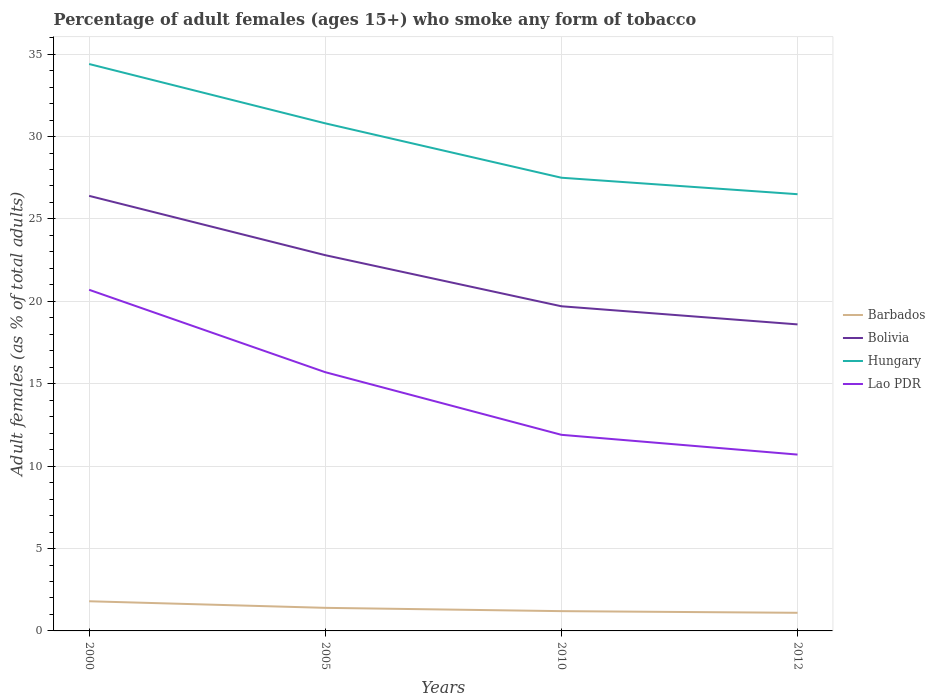How many different coloured lines are there?
Provide a short and direct response. 4. Does the line corresponding to Bolivia intersect with the line corresponding to Barbados?
Your response must be concise. No. Across all years, what is the maximum percentage of adult females who smoke in Barbados?
Provide a succinct answer. 1.1. What is the total percentage of adult females who smoke in Bolivia in the graph?
Provide a short and direct response. 1.1. What is the difference between the highest and the second highest percentage of adult females who smoke in Barbados?
Provide a short and direct response. 0.7. What is the difference between the highest and the lowest percentage of adult females who smoke in Barbados?
Ensure brevity in your answer.  2. How many lines are there?
Your answer should be very brief. 4. How many years are there in the graph?
Offer a terse response. 4. What is the difference between two consecutive major ticks on the Y-axis?
Provide a succinct answer. 5. Are the values on the major ticks of Y-axis written in scientific E-notation?
Make the answer very short. No. Does the graph contain any zero values?
Offer a very short reply. No. Does the graph contain grids?
Provide a succinct answer. Yes. How are the legend labels stacked?
Your response must be concise. Vertical. What is the title of the graph?
Your answer should be compact. Percentage of adult females (ages 15+) who smoke any form of tobacco. Does "Iraq" appear as one of the legend labels in the graph?
Offer a terse response. No. What is the label or title of the Y-axis?
Provide a succinct answer. Adult females (as % of total adults). What is the Adult females (as % of total adults) of Barbados in 2000?
Keep it short and to the point. 1.8. What is the Adult females (as % of total adults) in Bolivia in 2000?
Your response must be concise. 26.4. What is the Adult females (as % of total adults) of Hungary in 2000?
Your answer should be very brief. 34.4. What is the Adult females (as % of total adults) in Lao PDR in 2000?
Give a very brief answer. 20.7. What is the Adult females (as % of total adults) of Barbados in 2005?
Your answer should be compact. 1.4. What is the Adult females (as % of total adults) of Bolivia in 2005?
Provide a short and direct response. 22.8. What is the Adult females (as % of total adults) in Hungary in 2005?
Your answer should be compact. 30.8. What is the Adult females (as % of total adults) of Bolivia in 2010?
Offer a terse response. 19.7. What is the Adult females (as % of total adults) in Hungary in 2010?
Keep it short and to the point. 27.5. What is the Adult females (as % of total adults) of Bolivia in 2012?
Provide a succinct answer. 18.6. Across all years, what is the maximum Adult females (as % of total adults) in Bolivia?
Ensure brevity in your answer.  26.4. Across all years, what is the maximum Adult females (as % of total adults) of Hungary?
Give a very brief answer. 34.4. Across all years, what is the maximum Adult females (as % of total adults) of Lao PDR?
Your answer should be very brief. 20.7. Across all years, what is the minimum Adult females (as % of total adults) of Bolivia?
Provide a succinct answer. 18.6. Across all years, what is the minimum Adult females (as % of total adults) of Lao PDR?
Give a very brief answer. 10.7. What is the total Adult females (as % of total adults) of Bolivia in the graph?
Your answer should be compact. 87.5. What is the total Adult females (as % of total adults) of Hungary in the graph?
Your response must be concise. 119.2. What is the difference between the Adult females (as % of total adults) in Bolivia in 2000 and that in 2005?
Keep it short and to the point. 3.6. What is the difference between the Adult females (as % of total adults) in Hungary in 2000 and that in 2005?
Your answer should be very brief. 3.6. What is the difference between the Adult females (as % of total adults) in Lao PDR in 2000 and that in 2005?
Offer a terse response. 5. What is the difference between the Adult females (as % of total adults) of Barbados in 2000 and that in 2010?
Your response must be concise. 0.6. What is the difference between the Adult females (as % of total adults) of Hungary in 2000 and that in 2010?
Keep it short and to the point. 6.9. What is the difference between the Adult females (as % of total adults) in Lao PDR in 2000 and that in 2010?
Offer a very short reply. 8.8. What is the difference between the Adult females (as % of total adults) in Barbados in 2000 and that in 2012?
Offer a terse response. 0.7. What is the difference between the Adult females (as % of total adults) in Lao PDR in 2000 and that in 2012?
Give a very brief answer. 10. What is the difference between the Adult females (as % of total adults) in Barbados in 2005 and that in 2010?
Your answer should be very brief. 0.2. What is the difference between the Adult females (as % of total adults) of Hungary in 2005 and that in 2010?
Your answer should be compact. 3.3. What is the difference between the Adult females (as % of total adults) in Barbados in 2005 and that in 2012?
Your answer should be compact. 0.3. What is the difference between the Adult females (as % of total adults) of Barbados in 2010 and that in 2012?
Offer a terse response. 0.1. What is the difference between the Adult females (as % of total adults) of Bolivia in 2010 and that in 2012?
Provide a succinct answer. 1.1. What is the difference between the Adult females (as % of total adults) in Hungary in 2010 and that in 2012?
Offer a very short reply. 1. What is the difference between the Adult females (as % of total adults) of Lao PDR in 2010 and that in 2012?
Your response must be concise. 1.2. What is the difference between the Adult females (as % of total adults) in Barbados in 2000 and the Adult females (as % of total adults) in Hungary in 2005?
Provide a short and direct response. -29. What is the difference between the Adult females (as % of total adults) of Barbados in 2000 and the Adult females (as % of total adults) of Lao PDR in 2005?
Your answer should be very brief. -13.9. What is the difference between the Adult females (as % of total adults) in Barbados in 2000 and the Adult females (as % of total adults) in Bolivia in 2010?
Keep it short and to the point. -17.9. What is the difference between the Adult females (as % of total adults) in Barbados in 2000 and the Adult females (as % of total adults) in Hungary in 2010?
Offer a very short reply. -25.7. What is the difference between the Adult females (as % of total adults) of Barbados in 2000 and the Adult females (as % of total adults) of Lao PDR in 2010?
Ensure brevity in your answer.  -10.1. What is the difference between the Adult females (as % of total adults) of Bolivia in 2000 and the Adult females (as % of total adults) of Lao PDR in 2010?
Your response must be concise. 14.5. What is the difference between the Adult females (as % of total adults) in Hungary in 2000 and the Adult females (as % of total adults) in Lao PDR in 2010?
Your answer should be compact. 22.5. What is the difference between the Adult females (as % of total adults) of Barbados in 2000 and the Adult females (as % of total adults) of Bolivia in 2012?
Offer a terse response. -16.8. What is the difference between the Adult females (as % of total adults) of Barbados in 2000 and the Adult females (as % of total adults) of Hungary in 2012?
Give a very brief answer. -24.7. What is the difference between the Adult females (as % of total adults) of Hungary in 2000 and the Adult females (as % of total adults) of Lao PDR in 2012?
Your answer should be very brief. 23.7. What is the difference between the Adult females (as % of total adults) of Barbados in 2005 and the Adult females (as % of total adults) of Bolivia in 2010?
Make the answer very short. -18.3. What is the difference between the Adult females (as % of total adults) in Barbados in 2005 and the Adult females (as % of total adults) in Hungary in 2010?
Make the answer very short. -26.1. What is the difference between the Adult females (as % of total adults) of Bolivia in 2005 and the Adult females (as % of total adults) of Lao PDR in 2010?
Give a very brief answer. 10.9. What is the difference between the Adult females (as % of total adults) in Barbados in 2005 and the Adult females (as % of total adults) in Bolivia in 2012?
Keep it short and to the point. -17.2. What is the difference between the Adult females (as % of total adults) in Barbados in 2005 and the Adult females (as % of total adults) in Hungary in 2012?
Your response must be concise. -25.1. What is the difference between the Adult females (as % of total adults) of Barbados in 2005 and the Adult females (as % of total adults) of Lao PDR in 2012?
Offer a very short reply. -9.3. What is the difference between the Adult females (as % of total adults) of Hungary in 2005 and the Adult females (as % of total adults) of Lao PDR in 2012?
Give a very brief answer. 20.1. What is the difference between the Adult females (as % of total adults) of Barbados in 2010 and the Adult females (as % of total adults) of Bolivia in 2012?
Offer a very short reply. -17.4. What is the difference between the Adult females (as % of total adults) in Barbados in 2010 and the Adult females (as % of total adults) in Hungary in 2012?
Your answer should be very brief. -25.3. What is the average Adult females (as % of total adults) in Barbados per year?
Make the answer very short. 1.38. What is the average Adult females (as % of total adults) in Bolivia per year?
Offer a terse response. 21.88. What is the average Adult females (as % of total adults) in Hungary per year?
Give a very brief answer. 29.8. What is the average Adult females (as % of total adults) in Lao PDR per year?
Your answer should be compact. 14.75. In the year 2000, what is the difference between the Adult females (as % of total adults) of Barbados and Adult females (as % of total adults) of Bolivia?
Keep it short and to the point. -24.6. In the year 2000, what is the difference between the Adult females (as % of total adults) in Barbados and Adult females (as % of total adults) in Hungary?
Make the answer very short. -32.6. In the year 2000, what is the difference between the Adult females (as % of total adults) of Barbados and Adult females (as % of total adults) of Lao PDR?
Your answer should be compact. -18.9. In the year 2005, what is the difference between the Adult females (as % of total adults) in Barbados and Adult females (as % of total adults) in Bolivia?
Offer a terse response. -21.4. In the year 2005, what is the difference between the Adult females (as % of total adults) in Barbados and Adult females (as % of total adults) in Hungary?
Offer a terse response. -29.4. In the year 2005, what is the difference between the Adult females (as % of total adults) of Barbados and Adult females (as % of total adults) of Lao PDR?
Offer a terse response. -14.3. In the year 2005, what is the difference between the Adult females (as % of total adults) of Bolivia and Adult females (as % of total adults) of Hungary?
Ensure brevity in your answer.  -8. In the year 2005, what is the difference between the Adult females (as % of total adults) of Bolivia and Adult females (as % of total adults) of Lao PDR?
Offer a very short reply. 7.1. In the year 2010, what is the difference between the Adult females (as % of total adults) of Barbados and Adult females (as % of total adults) of Bolivia?
Your response must be concise. -18.5. In the year 2010, what is the difference between the Adult females (as % of total adults) of Barbados and Adult females (as % of total adults) of Hungary?
Make the answer very short. -26.3. In the year 2010, what is the difference between the Adult females (as % of total adults) of Barbados and Adult females (as % of total adults) of Lao PDR?
Give a very brief answer. -10.7. In the year 2010, what is the difference between the Adult females (as % of total adults) in Bolivia and Adult females (as % of total adults) in Lao PDR?
Your answer should be compact. 7.8. In the year 2012, what is the difference between the Adult females (as % of total adults) in Barbados and Adult females (as % of total adults) in Bolivia?
Your response must be concise. -17.5. In the year 2012, what is the difference between the Adult females (as % of total adults) in Barbados and Adult females (as % of total adults) in Hungary?
Your answer should be very brief. -25.4. In the year 2012, what is the difference between the Adult females (as % of total adults) of Barbados and Adult females (as % of total adults) of Lao PDR?
Your response must be concise. -9.6. In the year 2012, what is the difference between the Adult females (as % of total adults) in Bolivia and Adult females (as % of total adults) in Hungary?
Give a very brief answer. -7.9. In the year 2012, what is the difference between the Adult females (as % of total adults) of Bolivia and Adult females (as % of total adults) of Lao PDR?
Offer a very short reply. 7.9. What is the ratio of the Adult females (as % of total adults) of Barbados in 2000 to that in 2005?
Your answer should be compact. 1.29. What is the ratio of the Adult females (as % of total adults) in Bolivia in 2000 to that in 2005?
Your answer should be compact. 1.16. What is the ratio of the Adult females (as % of total adults) of Hungary in 2000 to that in 2005?
Give a very brief answer. 1.12. What is the ratio of the Adult females (as % of total adults) of Lao PDR in 2000 to that in 2005?
Your answer should be very brief. 1.32. What is the ratio of the Adult females (as % of total adults) of Bolivia in 2000 to that in 2010?
Your answer should be compact. 1.34. What is the ratio of the Adult females (as % of total adults) in Hungary in 2000 to that in 2010?
Ensure brevity in your answer.  1.25. What is the ratio of the Adult females (as % of total adults) of Lao PDR in 2000 to that in 2010?
Provide a succinct answer. 1.74. What is the ratio of the Adult females (as % of total adults) in Barbados in 2000 to that in 2012?
Offer a terse response. 1.64. What is the ratio of the Adult females (as % of total adults) of Bolivia in 2000 to that in 2012?
Ensure brevity in your answer.  1.42. What is the ratio of the Adult females (as % of total adults) of Hungary in 2000 to that in 2012?
Ensure brevity in your answer.  1.3. What is the ratio of the Adult females (as % of total adults) in Lao PDR in 2000 to that in 2012?
Offer a terse response. 1.93. What is the ratio of the Adult females (as % of total adults) of Barbados in 2005 to that in 2010?
Your response must be concise. 1.17. What is the ratio of the Adult females (as % of total adults) in Bolivia in 2005 to that in 2010?
Keep it short and to the point. 1.16. What is the ratio of the Adult females (as % of total adults) in Hungary in 2005 to that in 2010?
Offer a terse response. 1.12. What is the ratio of the Adult females (as % of total adults) of Lao PDR in 2005 to that in 2010?
Ensure brevity in your answer.  1.32. What is the ratio of the Adult females (as % of total adults) of Barbados in 2005 to that in 2012?
Offer a very short reply. 1.27. What is the ratio of the Adult females (as % of total adults) in Bolivia in 2005 to that in 2012?
Keep it short and to the point. 1.23. What is the ratio of the Adult females (as % of total adults) of Hungary in 2005 to that in 2012?
Your answer should be very brief. 1.16. What is the ratio of the Adult females (as % of total adults) of Lao PDR in 2005 to that in 2012?
Your response must be concise. 1.47. What is the ratio of the Adult females (as % of total adults) of Barbados in 2010 to that in 2012?
Offer a terse response. 1.09. What is the ratio of the Adult females (as % of total adults) of Bolivia in 2010 to that in 2012?
Your answer should be compact. 1.06. What is the ratio of the Adult females (as % of total adults) of Hungary in 2010 to that in 2012?
Offer a very short reply. 1.04. What is the ratio of the Adult females (as % of total adults) in Lao PDR in 2010 to that in 2012?
Give a very brief answer. 1.11. What is the difference between the highest and the second highest Adult females (as % of total adults) of Hungary?
Give a very brief answer. 3.6. What is the difference between the highest and the second highest Adult females (as % of total adults) in Lao PDR?
Provide a short and direct response. 5. What is the difference between the highest and the lowest Adult females (as % of total adults) of Barbados?
Your response must be concise. 0.7. What is the difference between the highest and the lowest Adult females (as % of total adults) in Bolivia?
Make the answer very short. 7.8. What is the difference between the highest and the lowest Adult females (as % of total adults) of Hungary?
Your answer should be compact. 7.9. What is the difference between the highest and the lowest Adult females (as % of total adults) in Lao PDR?
Provide a short and direct response. 10. 